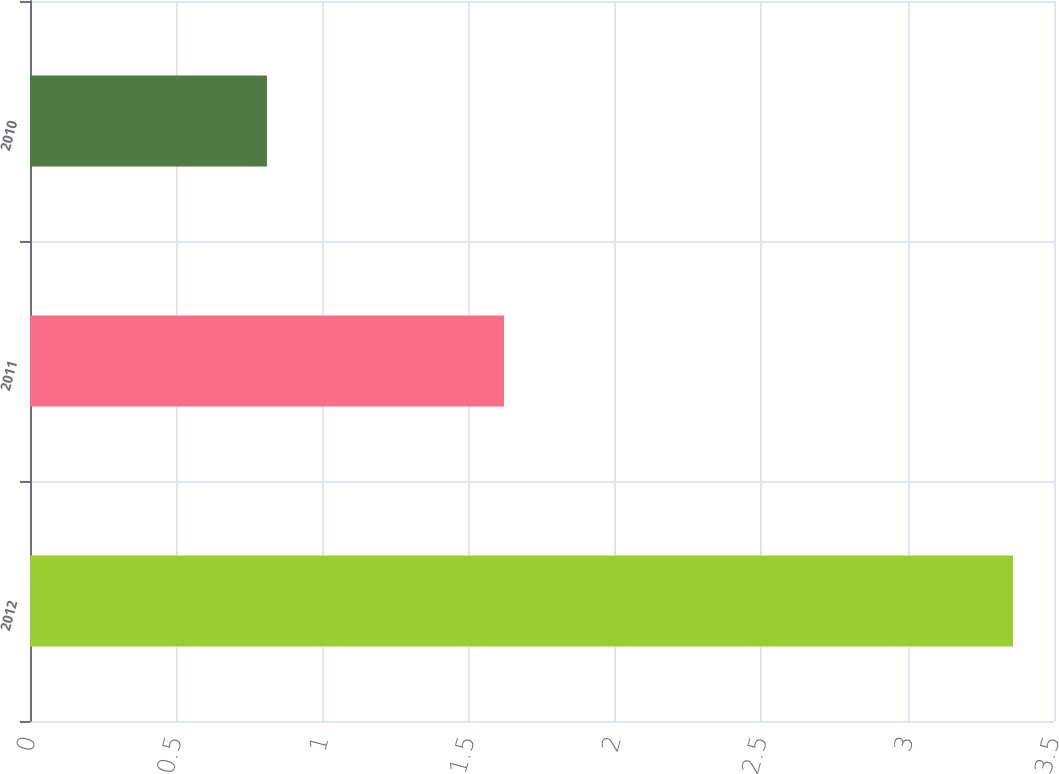<chart> <loc_0><loc_0><loc_500><loc_500><bar_chart><fcel>2012<fcel>2011<fcel>2010<nl><fcel>3.36<fcel>1.62<fcel>0.81<nl></chart> 